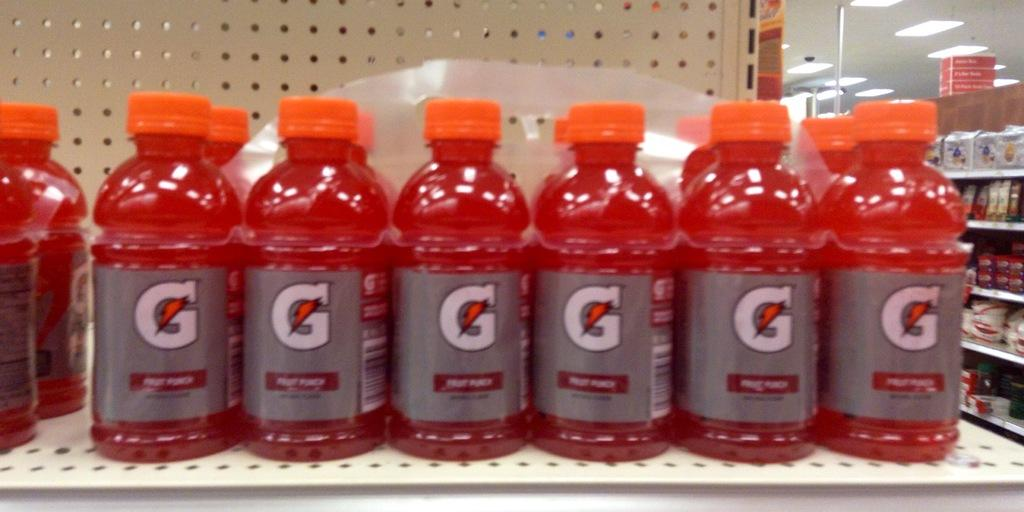<image>
Offer a succinct explanation of the picture presented. store shelf containing fruit punch flavored gatoraid that have silver labels and orange caps 